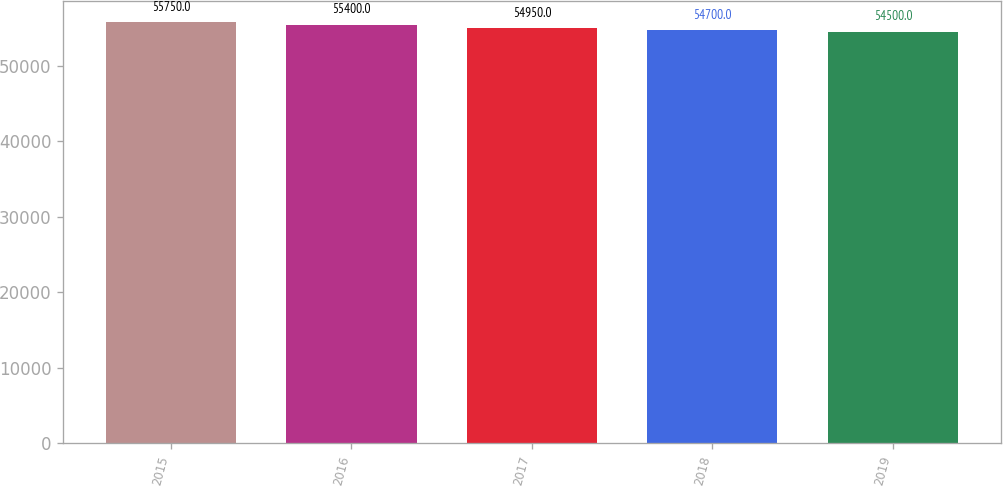<chart> <loc_0><loc_0><loc_500><loc_500><bar_chart><fcel>2015<fcel>2016<fcel>2017<fcel>2018<fcel>2019<nl><fcel>55750<fcel>55400<fcel>54950<fcel>54700<fcel>54500<nl></chart> 